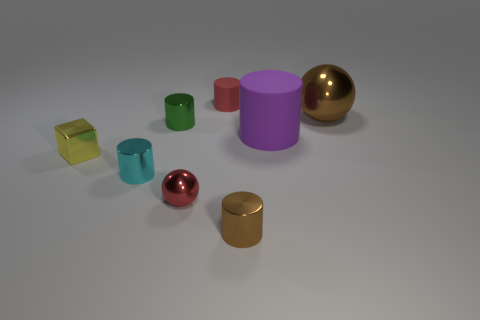Subtract all green cylinders. How many cylinders are left? 4 Subtract all brown cylinders. How many cylinders are left? 4 Subtract all yellow cylinders. Subtract all yellow spheres. How many cylinders are left? 5 Add 1 tiny matte objects. How many objects exist? 9 Subtract all cubes. How many objects are left? 7 Subtract 0 purple spheres. How many objects are left? 8 Subtract all big purple cylinders. Subtract all brown shiny objects. How many objects are left? 5 Add 1 metallic blocks. How many metallic blocks are left? 2 Add 6 purple objects. How many purple objects exist? 7 